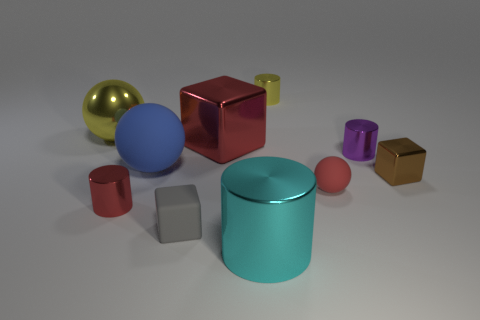If this represents a scale model, which object might be largest in real life? Assuming this is a scale model, the largest object in real life would likely be the teal cylinder, as it has the largest volume and footprint among the objects presented. 